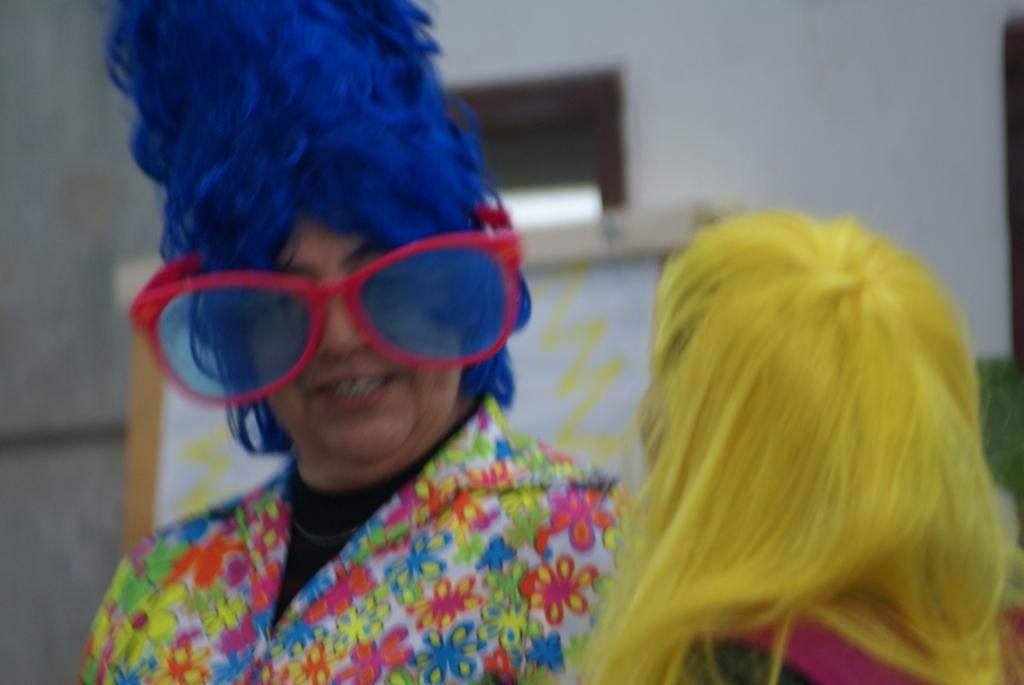Describe this image in one or two sentences. In this image in the foreground there are two persons who are wearing some costumes, and in the background there is a board and a window. 